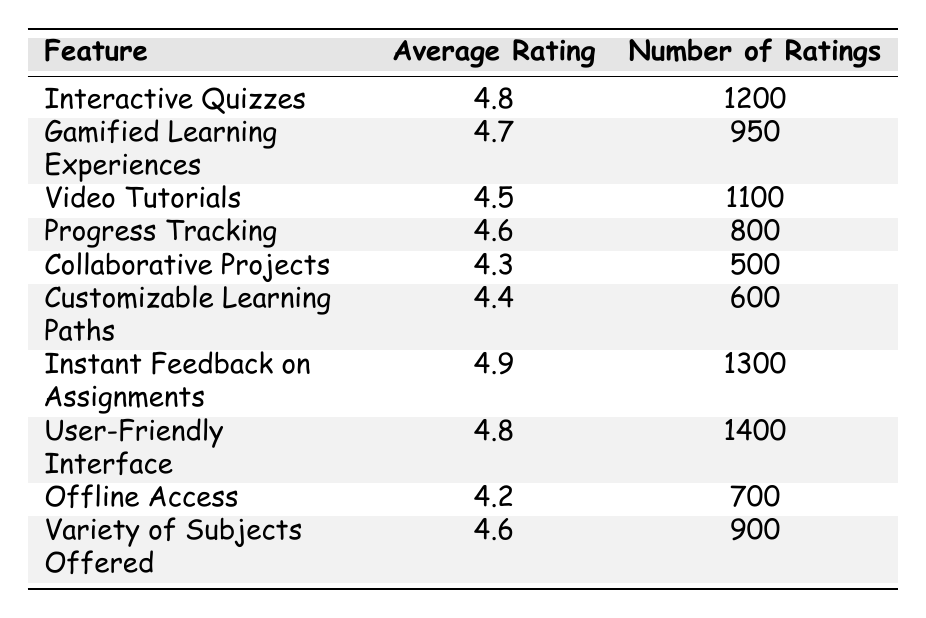What is the average rating for "Instant Feedback on Assignments"? The table shows that the average rating for "Instant Feedback on Assignments" is listed directly, which is 4.9.
Answer: 4.9 How many ratings were given for "User-Friendly Interface"? The table states that the number of ratings for "User-Friendly Interface" is 1400.
Answer: 1400 Which feature has the highest average rating? By comparing the average ratings in the table, "Instant Feedback on Assignments" has the highest average rating of 4.9.
Answer: Instant Feedback on Assignments What is the average rating of "Collaborative Projects" and "Customizable Learning Paths"? The average rating for "Collaborative Projects" is 4.3 and for "Customizable Learning Paths" it is 4.4. Adding these gives 4.3 + 4.4 = 8.7, and the average is 8.7 / 2 = 4.35.
Answer: 4.35 Is the average rating for "Offline Access" higher than 4.5? The average rating for "Offline Access" is 4.2, which is less than 4.5, so the answer is no.
Answer: No How many total ratings were given for all features combined? Adding the number of ratings for all features: 1200 + 950 + 1100 + 800 + 500 + 600 + 1300 + 1400 + 700 + 900 = 7550.
Answer: 7550 Which features have an average rating above 4.6? The features with average ratings above 4.6 are "Interactive Quizzes" (4.8), "Instant Feedback on Assignments" (4.9), and "User-Friendly Interface" (4.8), and "Variety of Subjects Offered" (4.6).
Answer: Interactive Quizzes, Instant Feedback on Assignments, User-Friendly Interface, Variety of Subjects Offered What is the difference in average ratings between "Gamified Learning Experiences" and "Progress Tracking"? The average rating for "Gamified Learning Experiences" is 4.7 and for "Progress Tracking" is 4.6. The difference is 4.7 - 4.6 = 0.1.
Answer: 0.1 How many more ratings did "Instant Feedback on Assignments" receive compared to "Collaborative Projects"? "Instant Feedback on Assignments" has 1300 ratings, while "Collaborative Projects" has 500 ratings. The difference is 1300 - 500 = 800.
Answer: 800 Is it true that "Video Tutorials" received more ratings than "Offline Access"? "Video Tutorials" has 1100 ratings and "Offline Access" has 700 ratings. Since 1100 is greater than 700, the statement is true.
Answer: Yes 